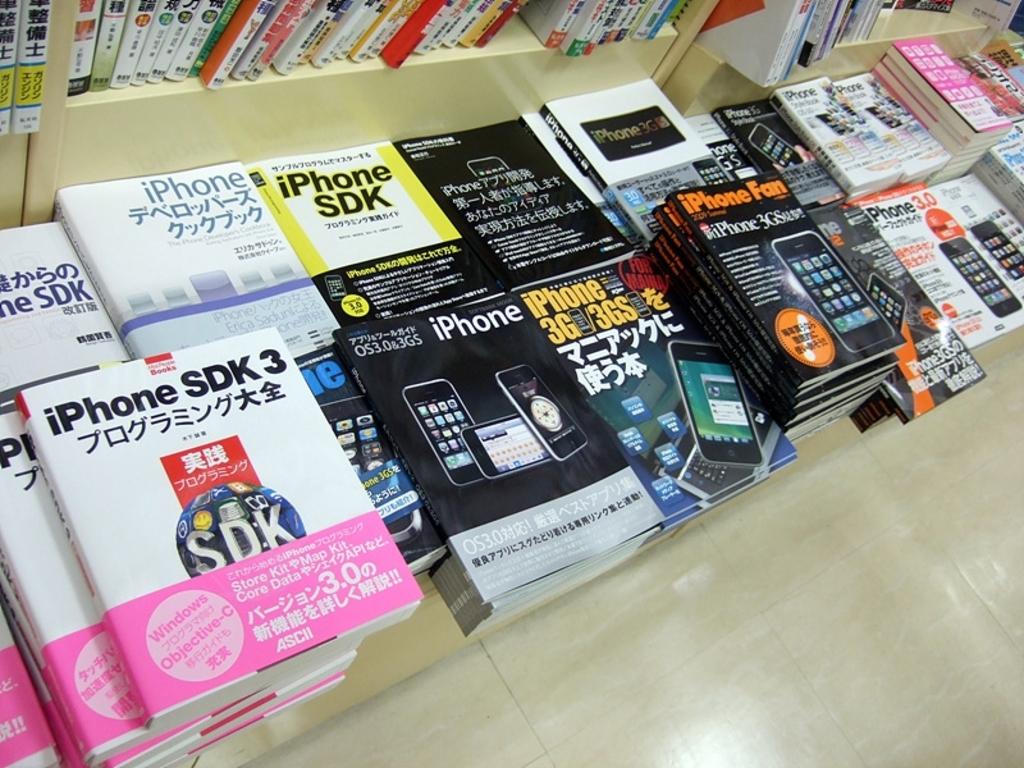What type of phone is mentioned on these books?
Your response must be concise. Iphone. 